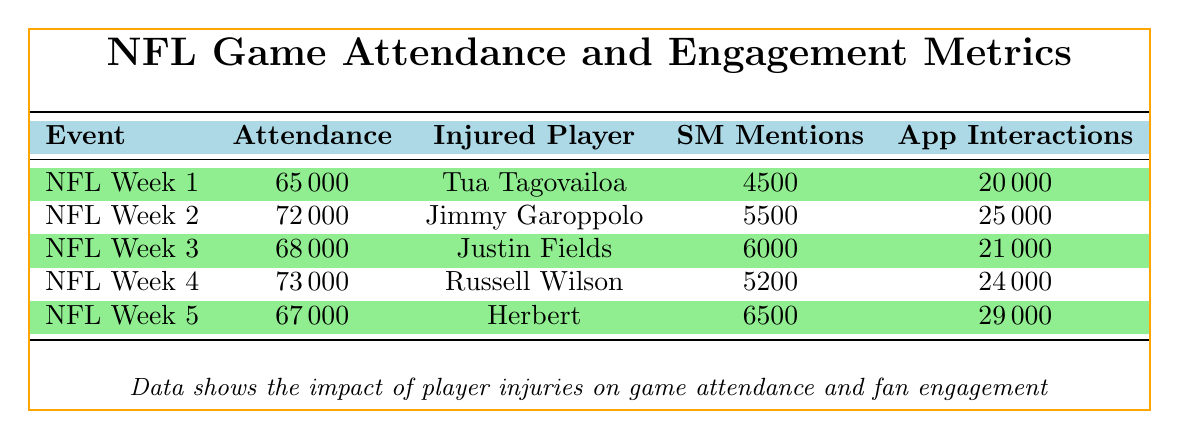What is the attendance for NFL Week 2? The table lists the attendance for each event under the Attendance column. For NFL Week 2 (Rams vs. 49ers), the attendance is 72000.
Answer: 72000 How many social media mentions were there for the NFL Week 5 event? The table indicates the social media mentions for NFL Week 5 (Chiefs vs. Chargers) in the Social Media Mentions column. The value is 6500.
Answer: 6500 Was Tua Tagovailoa injured during NFL Week 1? According to the player status in the table, Tua Tagovailoa is marked as injured for NFL Week 1.
Answer: Yes Which game had the highest attendance? By comparing the Attendance column, NFL Week 4 (Seahawks vs. Giants) has the highest attendance of 73000 among all listed events.
Answer: 73000 What is the average attendance across all five games? To find the average, we sum the attendances: 65000 + 72000 + 68000 + 73000 + 67000 = 355000. Then, we divide by the number of games (5), resulting in 355000 / 5 = 71000.
Answer: 71000 How many app interactions were recorded during NFL Week 3? The app interactions for NFL Week 3 (Packers vs. Bears) are listed in the App Interactions column. The value is 21000.
Answer: 21000 What percentage of events had injured players? There are 5 events, and all of them have at least one injured player. Therefore, the calculation is (5/5) * 100 = 100%.
Answer: 100% If Tua Tagovailoa recovers in 3 weeks, when will he be available again? Since the event took place on 2023-09-10 and he needs 3 weeks to recover, adding 21 days (3 weeks) to that date gives us 2023-09-10 + 21 days = 2023-09-30. He will be available on this date.
Answer: 2023-09-30 What is the difference in social media mentions between NFL Week 2 and NFL Week 4? The table shows 5500 social media mentions for NFL Week 2 and 5200 for NFL Week 4. The difference is 5500 - 5200 = 300.
Answer: 300 Which player had the longest recovery time among all listed injured players? Reviewing the recovery times, Russell Wilson has a recovery time of 5 weeks, which is longer than others: Tua (3 weeks), Jimmy (2 weeks), Justin (4 weeks), and Herbert (1 week).
Answer: Russell Wilson (5 weeks) 